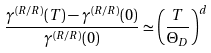<formula> <loc_0><loc_0><loc_500><loc_500>\frac { \gamma ^ { ( R / R ) } ( T ) - \gamma ^ { ( R / R ) } ( 0 ) } { \gamma ^ { ( R / R ) } ( 0 ) } \simeq \left ( \frac { T } { \Theta _ { D } } \right ) ^ { d }</formula> 